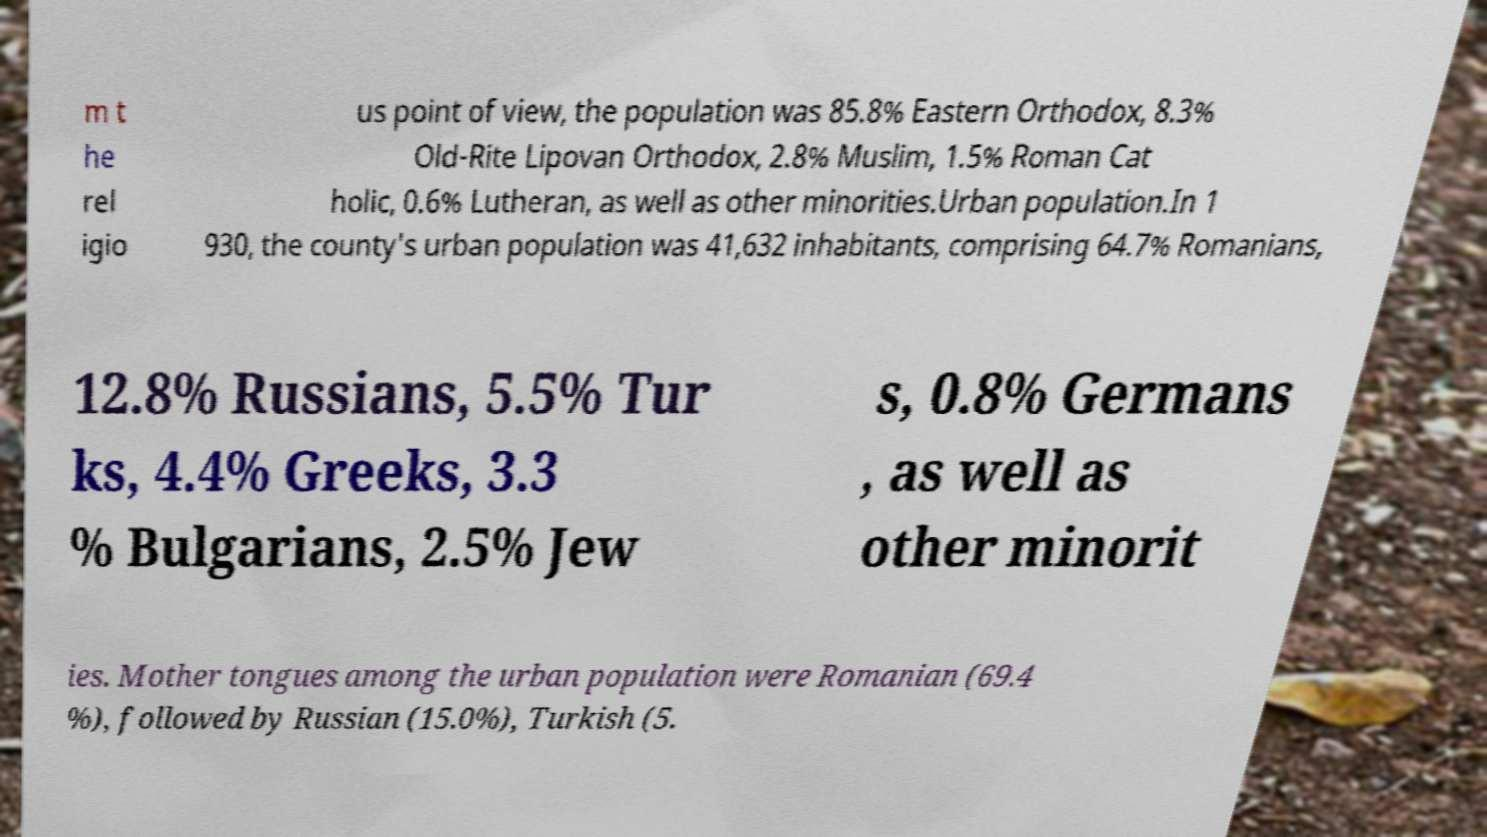There's text embedded in this image that I need extracted. Can you transcribe it verbatim? m t he rel igio us point of view, the population was 85.8% Eastern Orthodox, 8.3% Old-Rite Lipovan Orthodox, 2.8% Muslim, 1.5% Roman Cat holic, 0.6% Lutheran, as well as other minorities.Urban population.In 1 930, the county's urban population was 41,632 inhabitants, comprising 64.7% Romanians, 12.8% Russians, 5.5% Tur ks, 4.4% Greeks, 3.3 % Bulgarians, 2.5% Jew s, 0.8% Germans , as well as other minorit ies. Mother tongues among the urban population were Romanian (69.4 %), followed by Russian (15.0%), Turkish (5. 